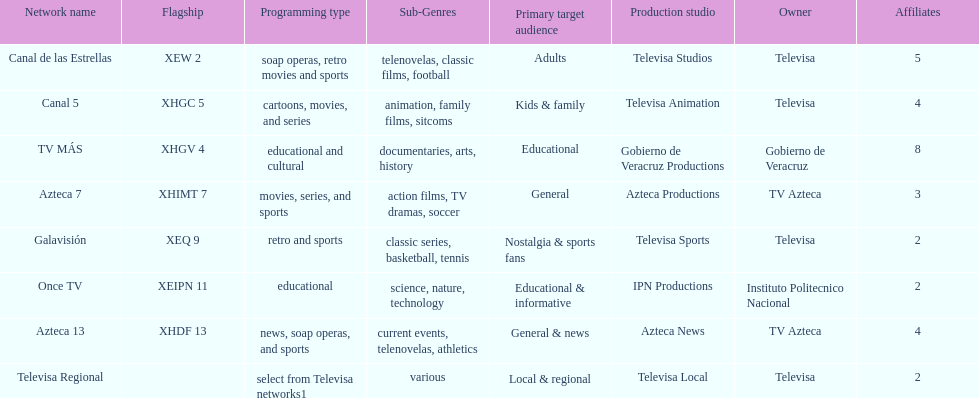How many channels broadcast soap operas? 2. 